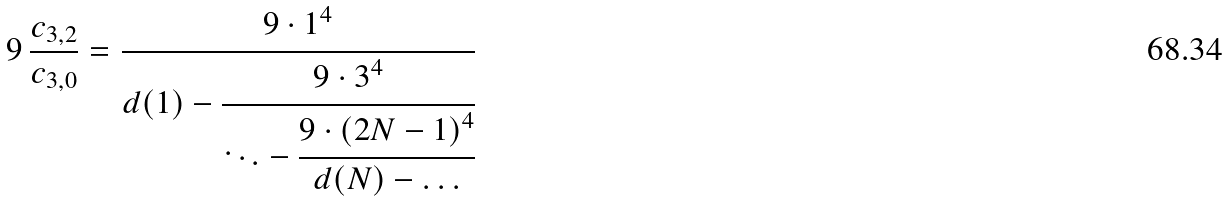<formula> <loc_0><loc_0><loc_500><loc_500>9 \, \frac { c _ { 3 , 2 } } { c _ { 3 , 0 } } = \cfrac { 9 \cdot 1 ^ { 4 } } { d ( 1 ) - \cfrac { 9 \cdot 3 ^ { 4 } } { \ddots - \cfrac { 9 \cdot ( 2 N - 1 ) ^ { 4 } } { d ( N ) - \dots } } }</formula> 